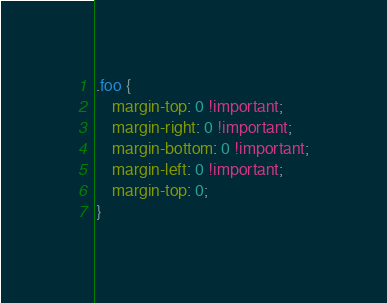Convert code to text. <code><loc_0><loc_0><loc_500><loc_500><_CSS_>.foo {
    margin-top: 0 !important;
    margin-right: 0 !important;
    margin-bottom: 0 !important;
    margin-left: 0 !important;
    margin-top: 0;
}</code> 